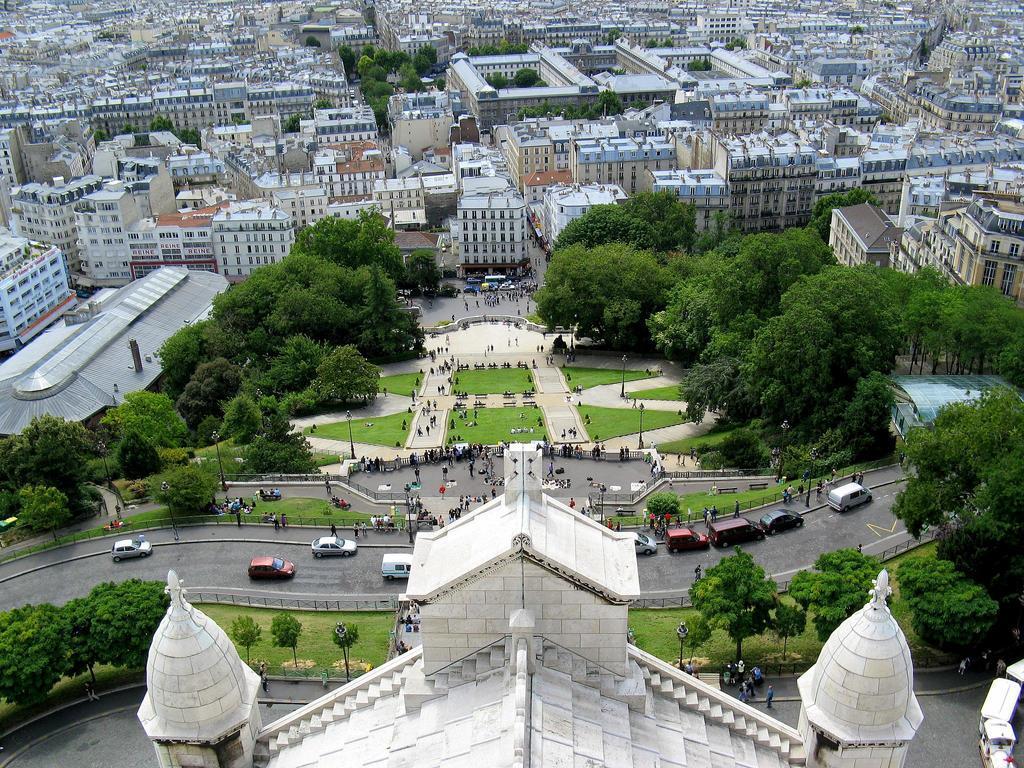Could you give a brief overview of what you see in this image? In this image I can see few buildings, windows, trees, poles, few people and few vehicles on the road. 